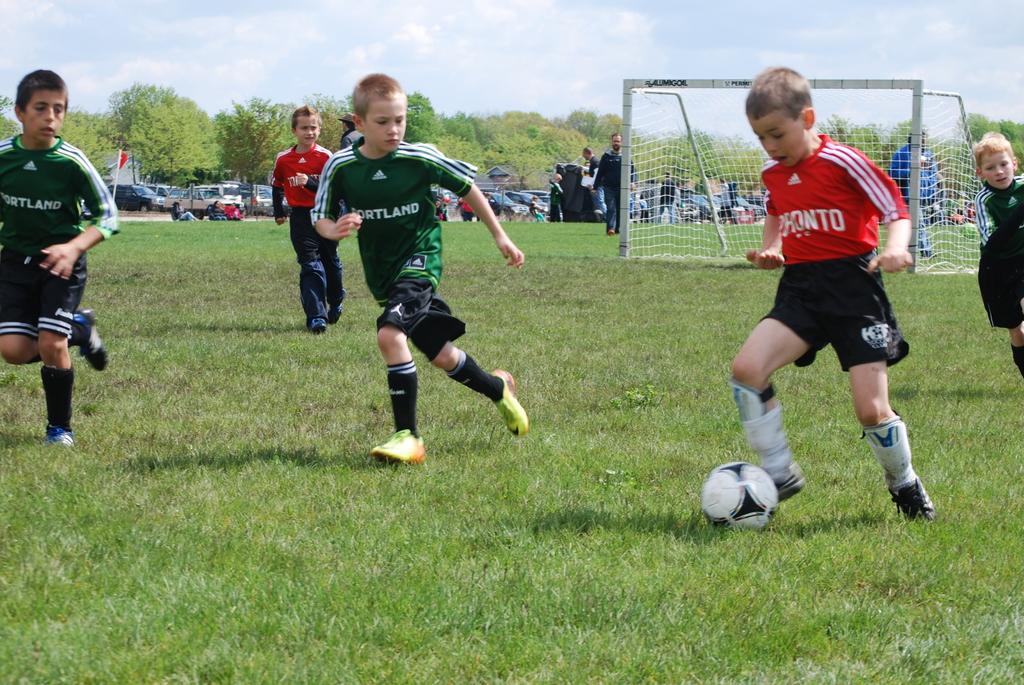What city is on the green jersey?
Make the answer very short. Portland. 